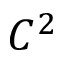Convert formula to latex. <formula><loc_0><loc_0><loc_500><loc_500>C ^ { 2 }</formula> 